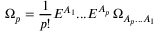Convert formula to latex. <formula><loc_0><loc_0><loc_500><loc_500>\Omega _ { p } = \frac { 1 } { p ! } E ^ { A _ { 1 } } \dots E ^ { A _ { p } } \, \Omega _ { { A _ { p } } \dots { A _ { 1 } } }</formula> 